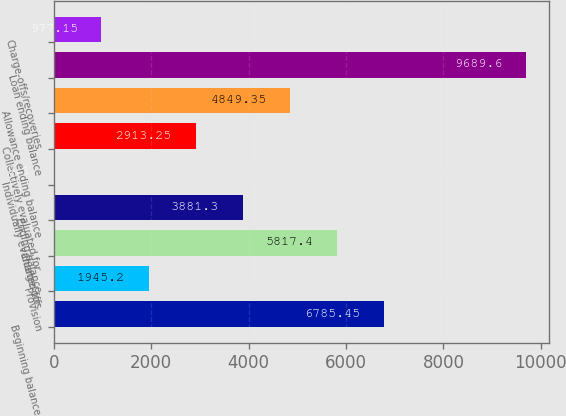Convert chart. <chart><loc_0><loc_0><loc_500><loc_500><bar_chart><fcel>Beginning balance<fcel>Provision<fcel>Charge-offs<fcel>Ending balance<fcel>Individually evaluated for<fcel>Collectively evaluated for<fcel>Allowance ending balance<fcel>Loan ending balance<fcel>Charge-offs/recoveries<nl><fcel>6785.45<fcel>1945.2<fcel>5817.4<fcel>3881.3<fcel>9.1<fcel>2913.25<fcel>4849.35<fcel>9689.6<fcel>977.15<nl></chart> 